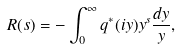<formula> <loc_0><loc_0><loc_500><loc_500>R ( s ) = - \int _ { 0 } ^ { \infty } q ^ { * } ( i y ) y ^ { s } \frac { d y } { y } ,</formula> 